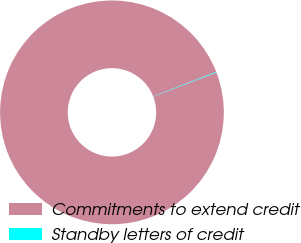Convert chart. <chart><loc_0><loc_0><loc_500><loc_500><pie_chart><fcel>Commitments to extend credit<fcel>Standby letters of credit<nl><fcel>99.91%<fcel>0.09%<nl></chart> 